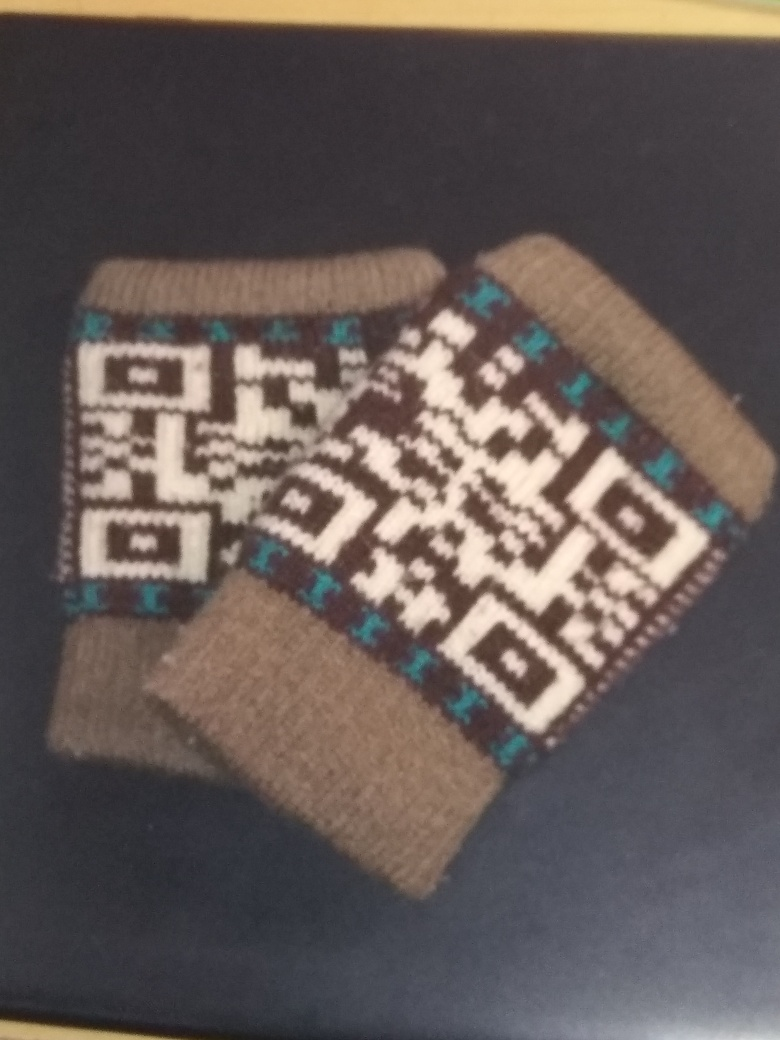Could you suggest suitable occasions or settings where these socks might be worn? These knitted woolen socks would be ideal for casual indoor wear, especially during the winter months. They could also be a thoughtful gift during the holidays or cherished as a cozy accessory for a comfortable day at home. 